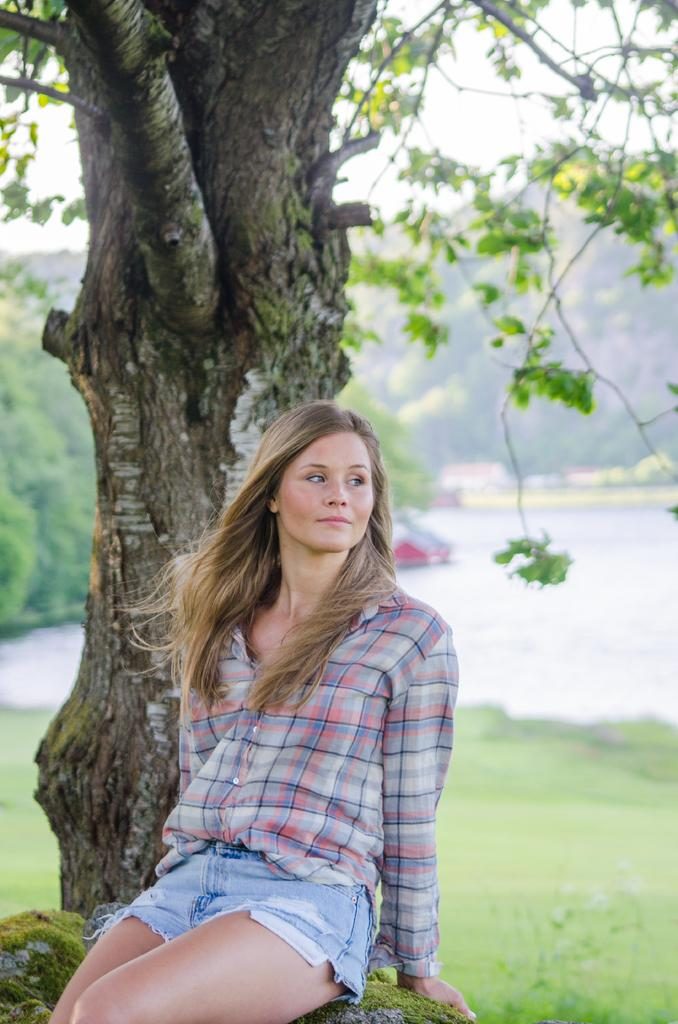What type of vegetation is present in the image? There is grass in the image. What else can be seen in the image besides grass? There is water, trees, and a woman sitting on a rock in the image. Where is the woman sitting in the image? The woman is sitting on a rock in the image. What is visible at the top of the image? The sky is visible at the top of the image. What type of beam is holding up the trees in the image? There is no beam present in the image; the trees are standing on their own. 